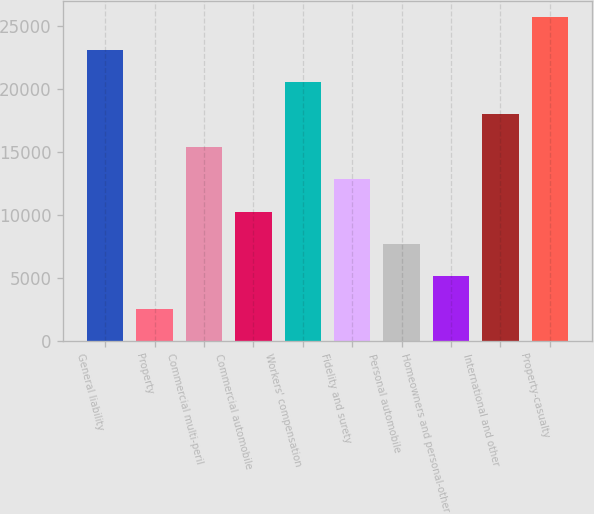Convert chart. <chart><loc_0><loc_0><loc_500><loc_500><bar_chart><fcel>General liability<fcel>Property<fcel>Commercial multi-peril<fcel>Commercial automobile<fcel>Workers' compensation<fcel>Fidelity and surety<fcel>Personal automobile<fcel>Homeowners and personal-other<fcel>International and other<fcel>Property-casualty<nl><fcel>23161.4<fcel>2580.6<fcel>15443.6<fcel>10298.4<fcel>20588.8<fcel>12871<fcel>7725.8<fcel>5153.2<fcel>18016.2<fcel>25734<nl></chart> 